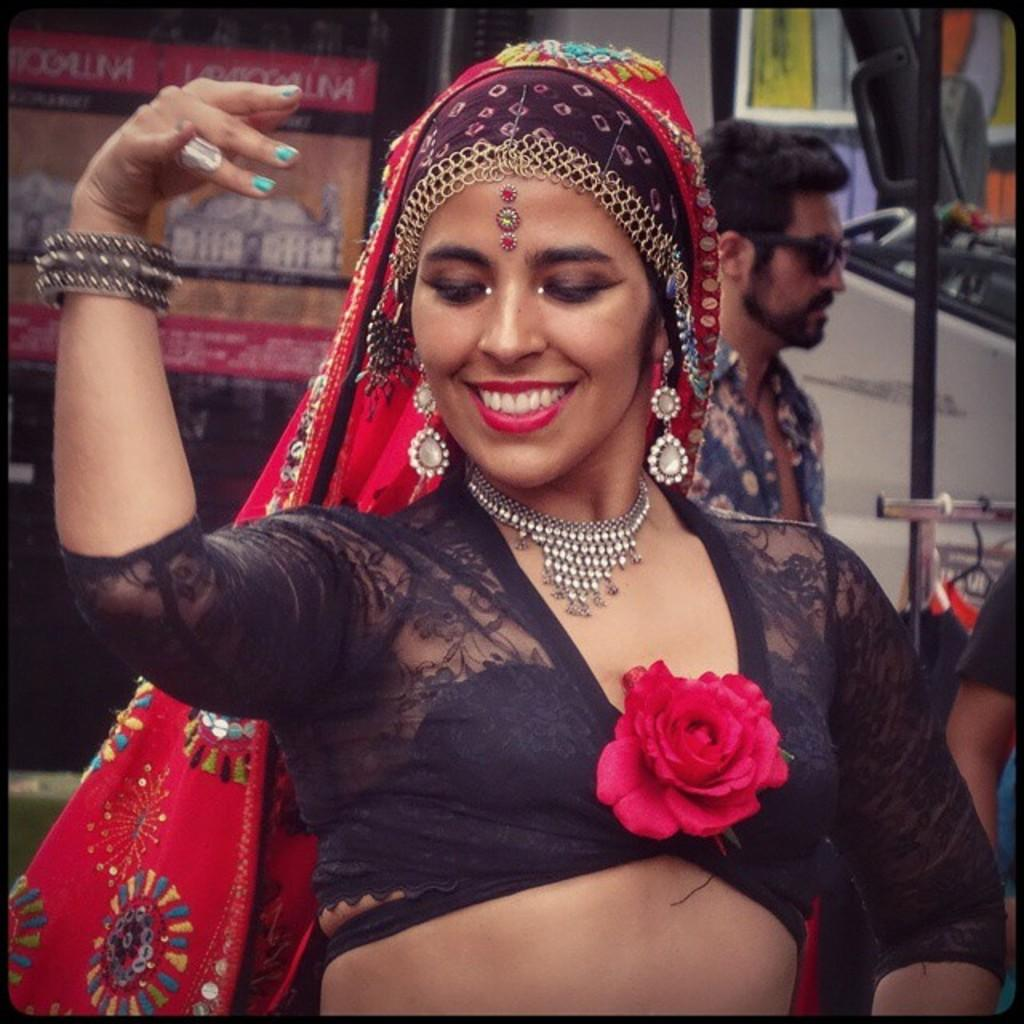What is the main subject in the foreground of the image? There is a lady in the foreground of the image. What is the lady doing in the image? The lady is dancing. What is the lady's facial expression in the image? The lady has a smiling face. What can be seen in the background of the image? There are many people, vehicles, and hoardings in the background of the image. What type of sock is the lady wearing in the image? There is no mention of a sock in the image, so it cannot be determined what type of sock the lady is wearing. 